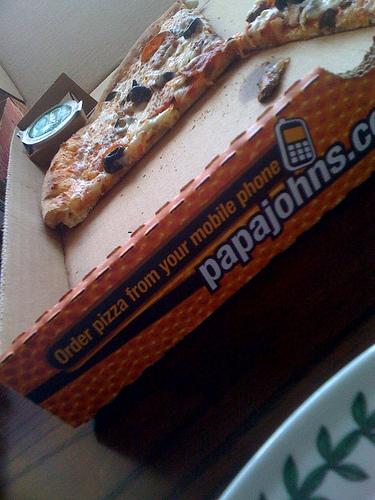Does the pizza come with dipping sauce?
Short answer required. Yes. Approximately how much pizza is gone?
Give a very brief answer. Half. What company delivered the pizza?
Answer briefly. Papa john's. 